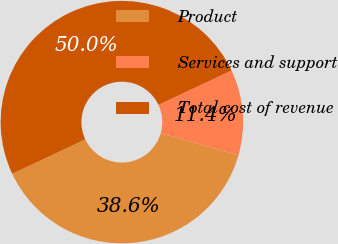Convert chart. <chart><loc_0><loc_0><loc_500><loc_500><pie_chart><fcel>Product<fcel>Services and support<fcel>Total cost of revenue<nl><fcel>38.57%<fcel>11.43%<fcel>50.0%<nl></chart> 